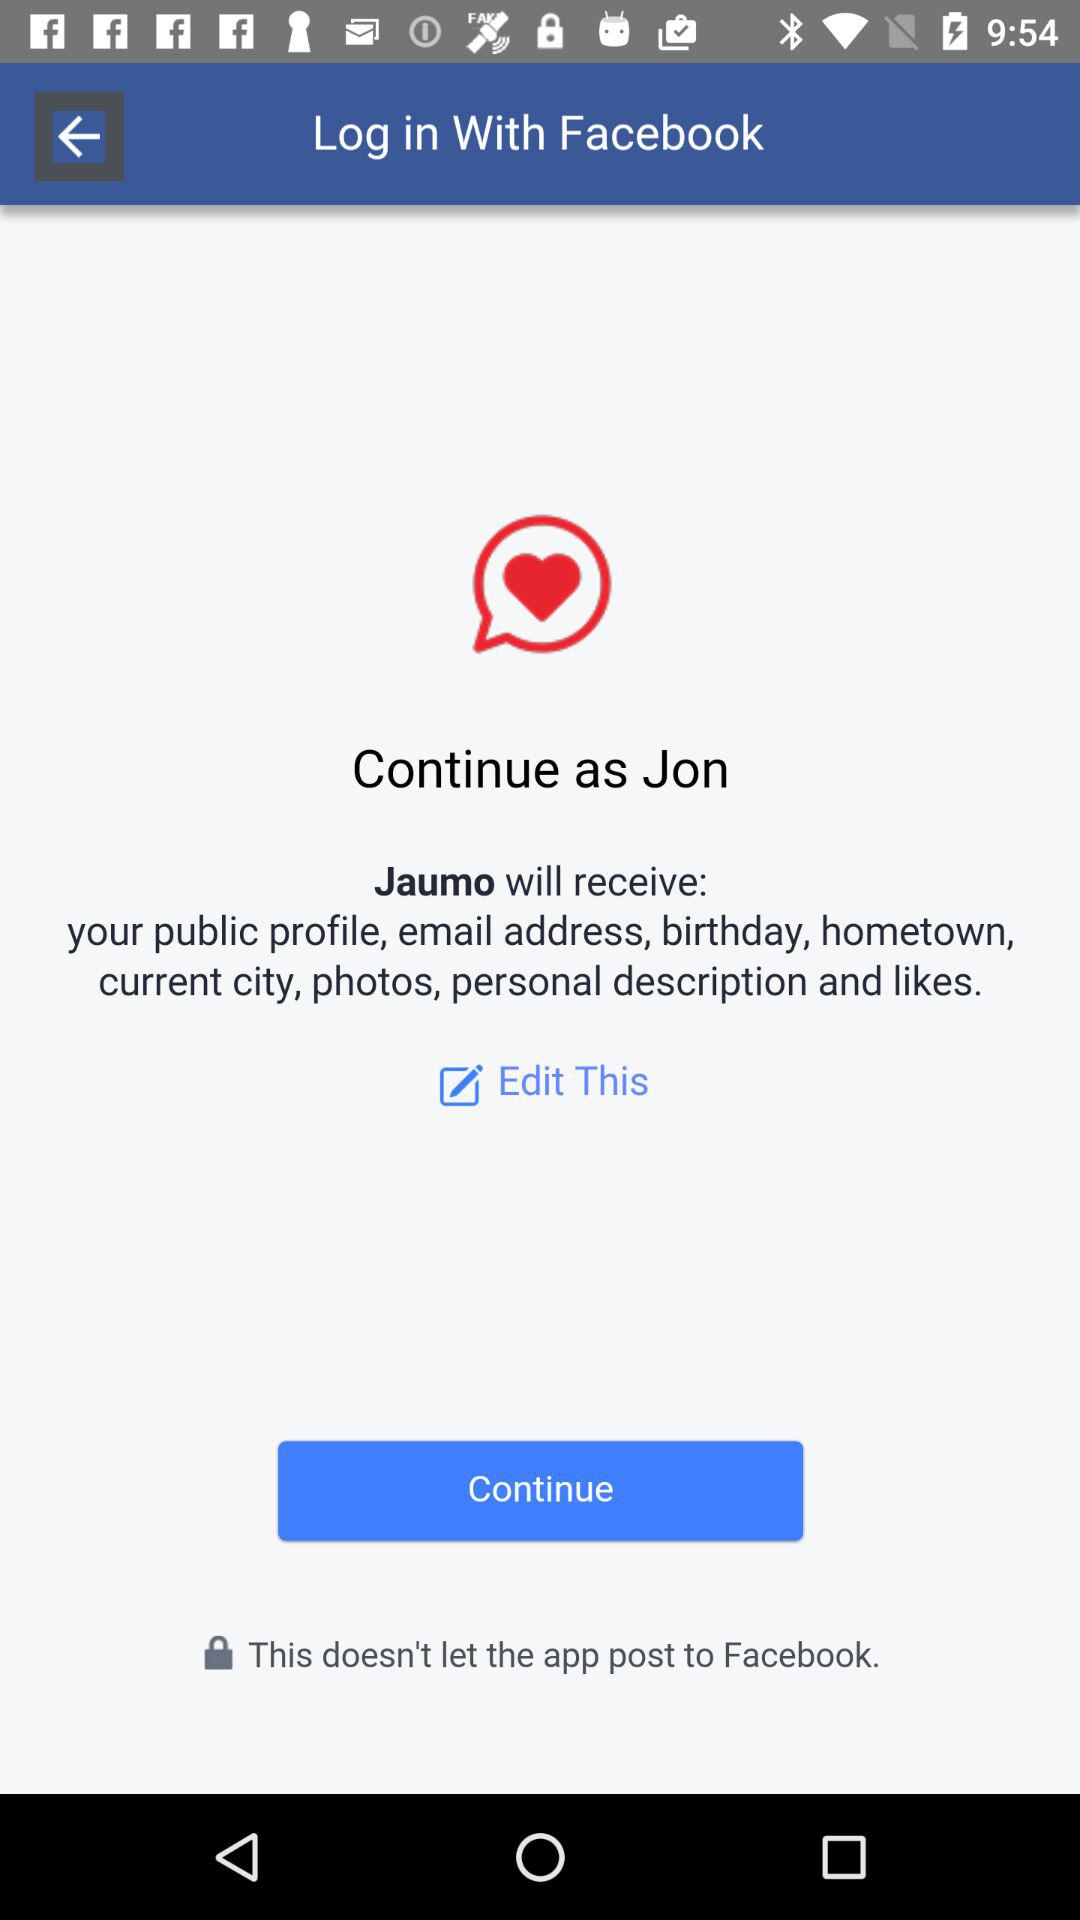What is the name of the application that can be used to log in? The name of the application is "Facebook". 